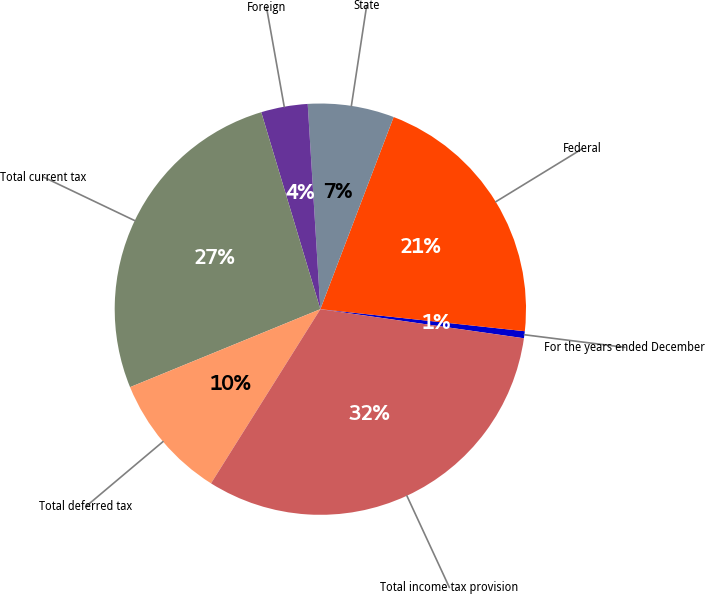Convert chart. <chart><loc_0><loc_0><loc_500><loc_500><pie_chart><fcel>For the years ended December<fcel>Federal<fcel>State<fcel>Foreign<fcel>Total current tax<fcel>Total deferred tax<fcel>Total income tax provision<nl><fcel>0.55%<fcel>20.91%<fcel>6.78%<fcel>3.66%<fcel>26.55%<fcel>9.89%<fcel>31.66%<nl></chart> 